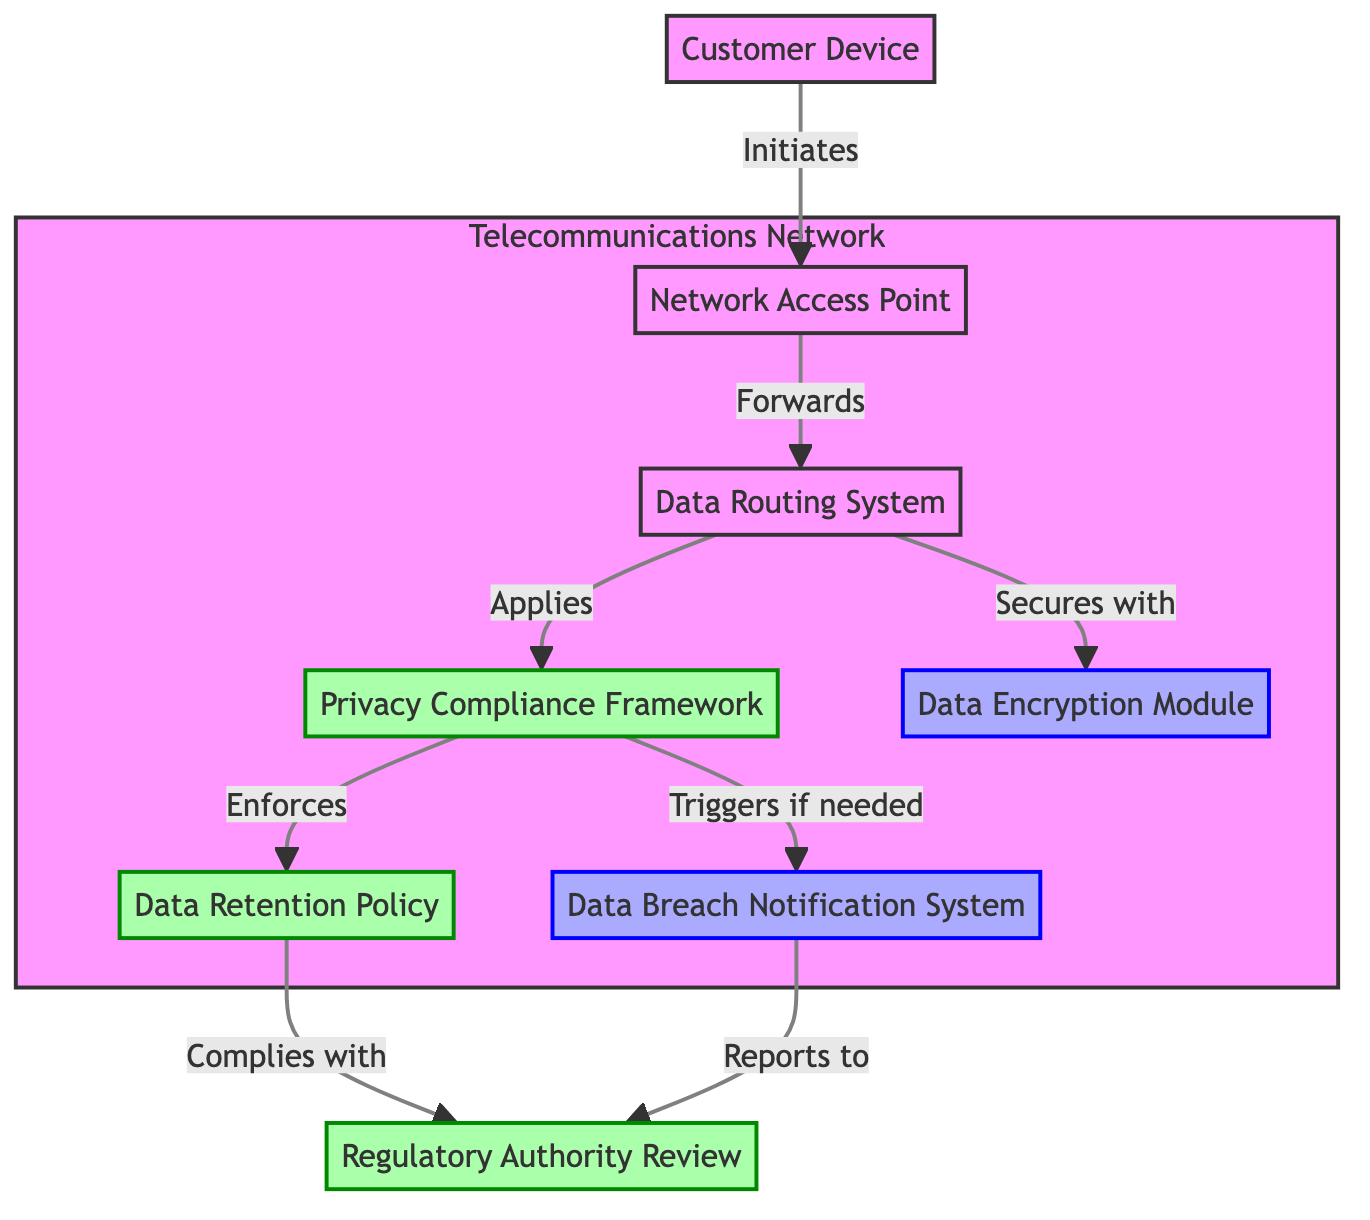What is the first node in the flow? The first node is the entry point into the flow and is labeled "Customer Device." This is where the flow begins as it represents the devices initiating user data transmission.
Answer: Customer Device How many nodes are present in the diagram? By counting all the distinct elements in the diagram, we identify eight nodes: Customer Device, Network Access Point, Data Routing System, Privacy Compliance Framework, Data Encryption Module, Data Retention Policy, Data Breach Notification System, and Regulatory Authority Review.
Answer: Eight Which node secures the customer data? The node responsible for securing customer data in transmission is labeled "Data Encryption Module." It indicates the component that protects customer data from unauthorized access during its flow through the network.
Answer: Data Encryption Module What does the Data Routing System apply? The Data Routing System applies the "Privacy Compliance Framework." This indicates that the routing of customer data is conducted according to the established privacy protocols.
Answer: Privacy Compliance Framework What happens if there is a data breach? In case of a data breach, the Data Breach Notification System triggers the process to inform both customers and regulatory authorities, ensuring compliance with the necessary legal obligations in response to data breaches.
Answer: Triggers What is required for compliance under the Privacy Compliance Framework? The Privacy Compliance Framework enforces the "Data Retention Policy," which outlines the guidelines for how long customer data can be stored, ensuring compliance with privacy laws.
Answer: Data Retention Policy Where does the regulatory oversight occur? Regulatory oversight occurs at the node labeled "Regulatory Authority Review," which highlights the role of governmental bodies in ensuring that all privacy legislation is being followed.
Answer: Regulatory Authority Review What flows from the Data Breach Notification System to the Regulatory Authority Review? The flow from the Data Breach Notification System goes to the Regulatory Authority Review, indicating that breaches are reported to the regulatory authorities as part of compliance measures.
Answer: Reports to How does customer data enter the telecommunications network? Customer data enters the telecommunications network via the "Network Access Point," which is the entry point for customer devices, allowing their data transmission to commence within the network.
Answer: Network Access Point 